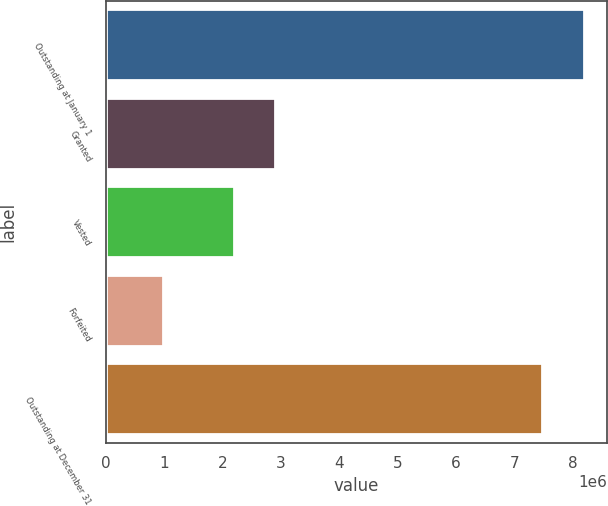Convert chart to OTSL. <chart><loc_0><loc_0><loc_500><loc_500><bar_chart><fcel>Outstanding at January 1<fcel>Granted<fcel>Vested<fcel>Forfeited<fcel>Outstanding at December 31<nl><fcel>8.17871e+06<fcel>2.90586e+06<fcel>2.19517e+06<fcel>989116<fcel>7.46802e+06<nl></chart> 